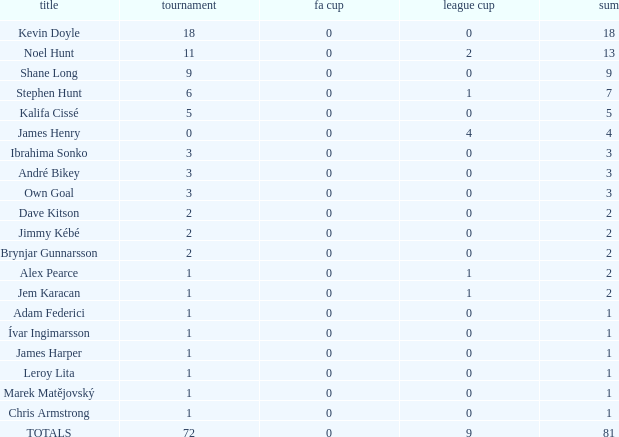In which championship has jem karacan achieved a total of 2 victories, with at least one league cup? 1.0. 